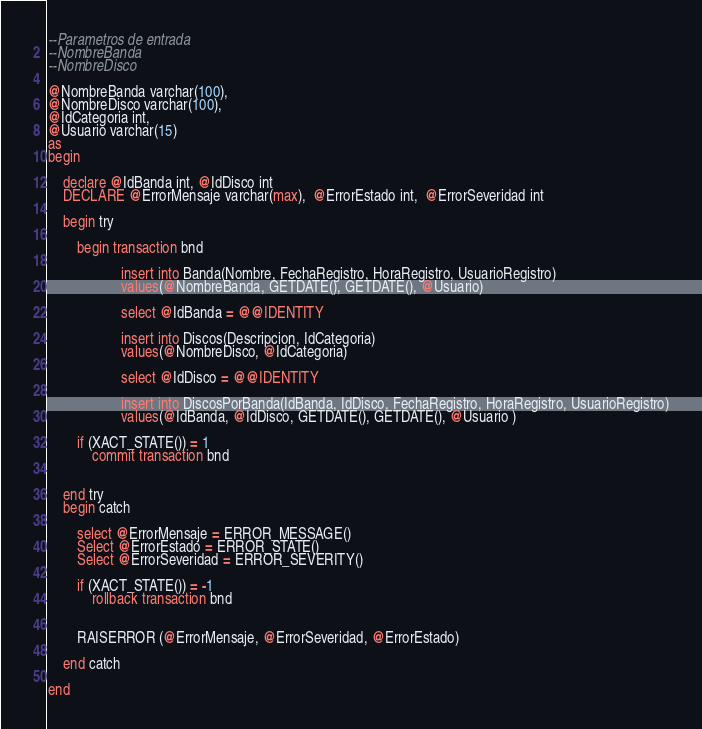<code> <loc_0><loc_0><loc_500><loc_500><_SQL_>--Parametros de entrada
--NombreBanda
--NombreDisco

@NombreBanda varchar(100),
@NombreDisco varchar(100),
@IdCategoria int,
@Usuario varchar(15)
as
begin

	declare @IdBanda int, @IdDisco int 
	DECLARE @ErrorMensaje varchar(max),  @ErrorEstado int,  @ErrorSeveridad int

	begin try
	
		begin transaction bnd
			
					insert into Banda(Nombre, FechaRegistro, HoraRegistro, UsuarioRegistro)
					values(@NombreBanda, GETDATE(), GETDATE(), @Usuario)
	
					select @IdBanda = @@IDENTITY

					insert into Discos(Descripcion, IdCategoria)
					values(@NombreDisco, @IdCategoria)

					select @IdDisco = @@IDENTITY
	
					insert into DiscosPorBanda(IdBanda, IdDisco, FechaRegistro, HoraRegistro, UsuarioRegistro)
					values(@IdBanda, @IdDisco, GETDATE(), GETDATE(), @Usuario )

		if (XACT_STATE()) = 1
			commit transaction bnd


	end try
	begin catch
		
		select @ErrorMensaje = ERROR_MESSAGE()
		Select @ErrorEstado = ERROR_STATE()
		Select @ErrorSeveridad = ERROR_SEVERITY()
		
		if (XACT_STATE()) = -1
			rollback transaction bnd


		RAISERROR (@ErrorMensaje, @ErrorSeveridad, @ErrorEstado)

	end catch

end</code> 